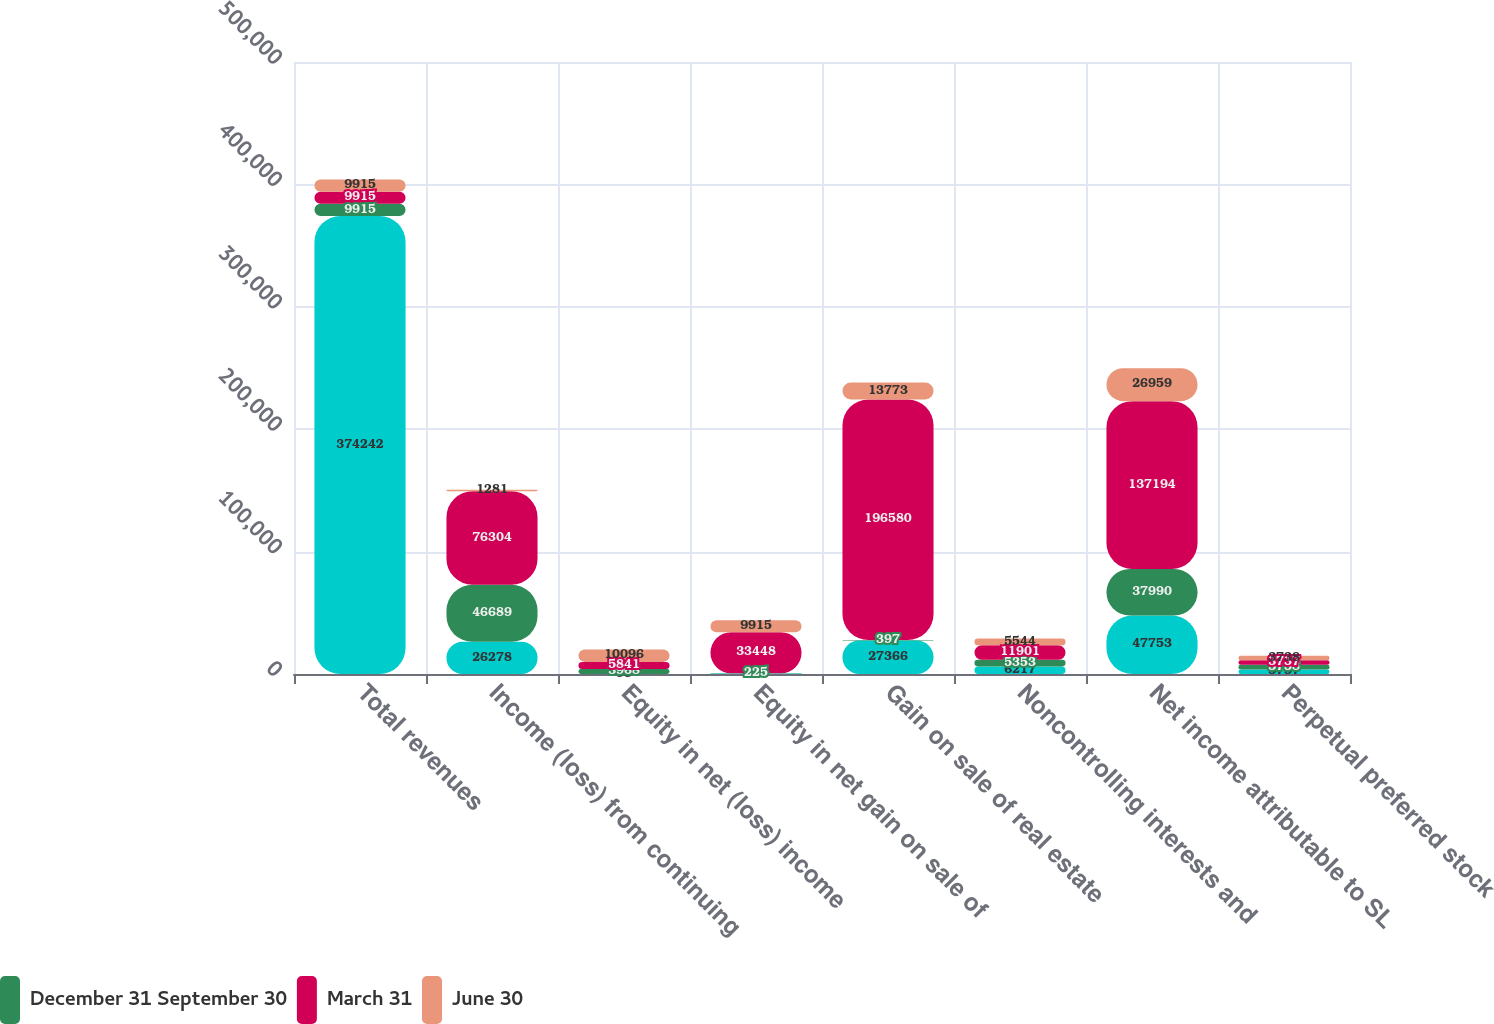<chart> <loc_0><loc_0><loc_500><loc_500><stacked_bar_chart><ecel><fcel>Total revenues<fcel>Income (loss) from continuing<fcel>Equity in net (loss) income<fcel>Equity in net gain on sale of<fcel>Gain on sale of real estate<fcel>Noncontrolling interests and<fcel>Net income attributable to SL<fcel>Perpetual preferred stock<nl><fcel>nan<fcel>374242<fcel>26278<fcel>95<fcel>421<fcel>27366<fcel>6217<fcel>47753<fcel>3737<nl><fcel>December 31 September 30<fcel>9915<fcel>46689<fcel>3968<fcel>225<fcel>397<fcel>5353<fcel>37990<fcel>3738<nl><fcel>March 31<fcel>9915<fcel>76304<fcel>5841<fcel>33448<fcel>196580<fcel>11901<fcel>137194<fcel>3737<nl><fcel>June 30<fcel>9915<fcel>1281<fcel>10096<fcel>9915<fcel>13773<fcel>5544<fcel>26959<fcel>3738<nl></chart> 